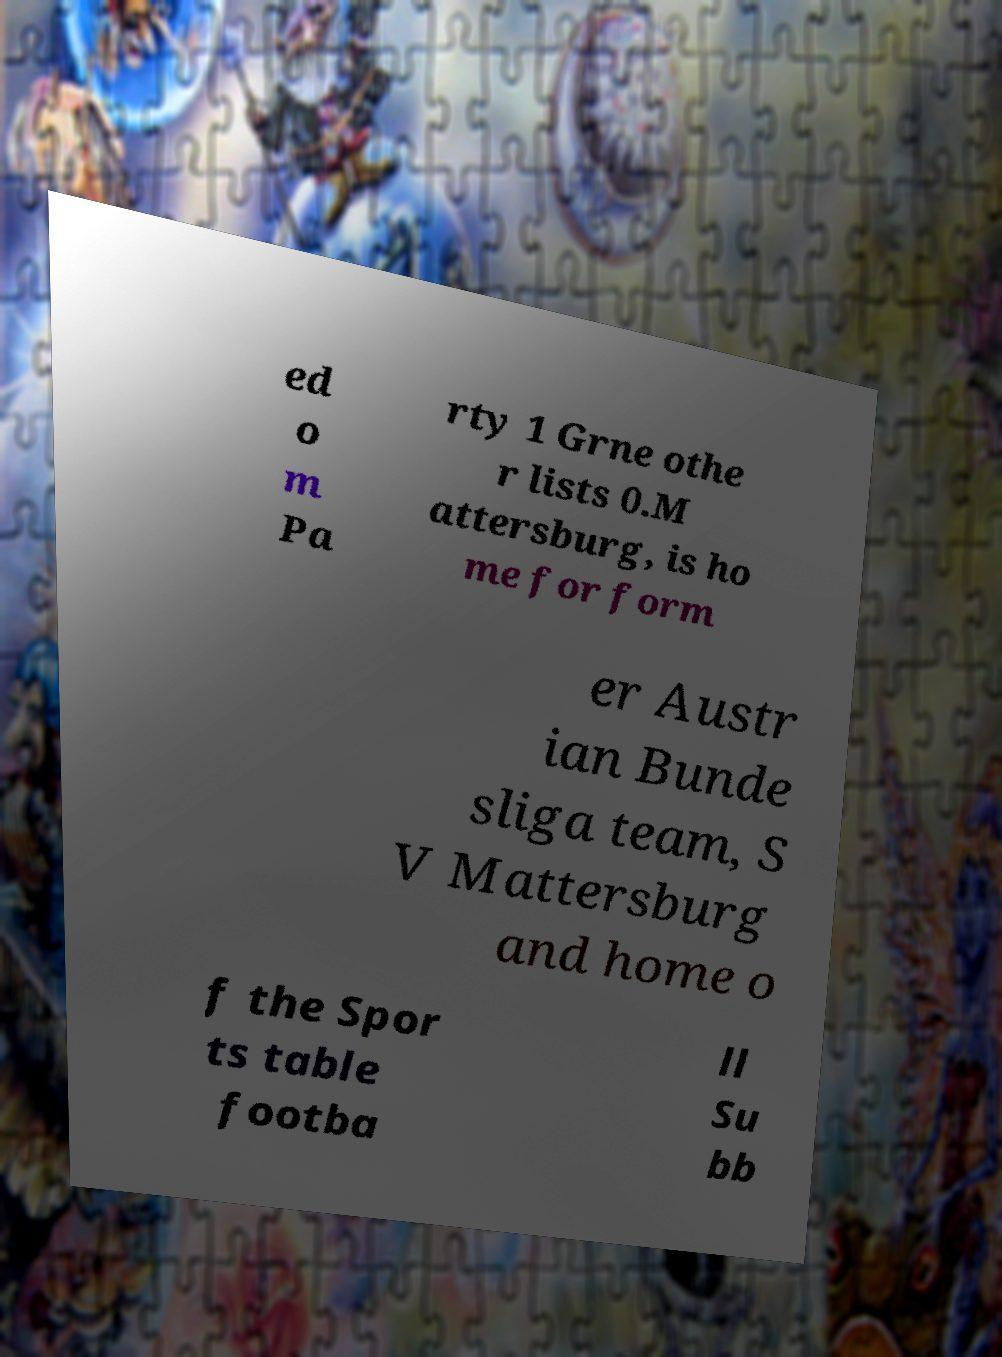Can you read and provide the text displayed in the image?This photo seems to have some interesting text. Can you extract and type it out for me? ed o m Pa rty 1 Grne othe r lists 0.M attersburg, is ho me for form er Austr ian Bunde sliga team, S V Mattersburg and home o f the Spor ts table footba ll Su bb 